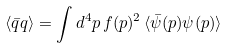<formula> <loc_0><loc_0><loc_500><loc_500>\langle \bar { q } q \rangle = \int d ^ { 4 } p \, f ( p ) ^ { 2 } \, \langle \bar { \psi } ( p ) \psi ( p ) \rangle</formula> 